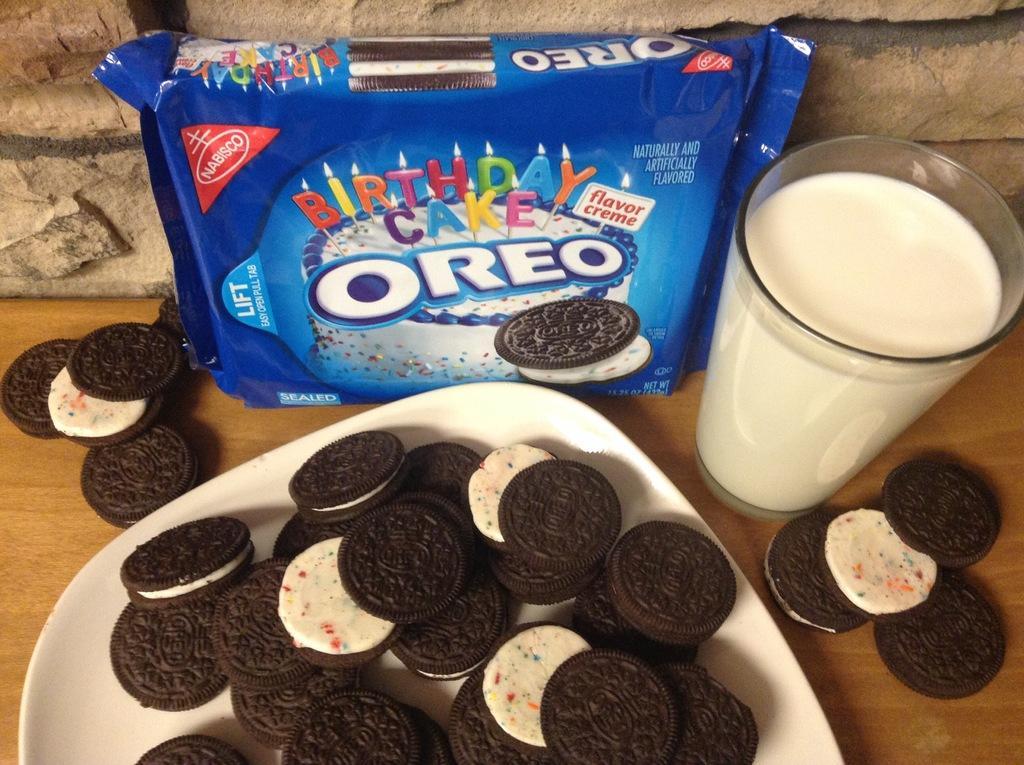Please provide a concise description of this image. In this image we can see some biscuits in a plate, a glass of milk and a cover which are placed on the table. We can also see some some biscuits on a table. On the top of the image we can see a wall. 